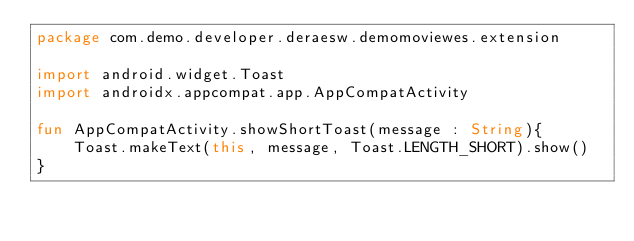Convert code to text. <code><loc_0><loc_0><loc_500><loc_500><_Kotlin_>package com.demo.developer.deraesw.demomoviewes.extension

import android.widget.Toast
import androidx.appcompat.app.AppCompatActivity

fun AppCompatActivity.showShortToast(message : String){
    Toast.makeText(this, message, Toast.LENGTH_SHORT).show()
}
</code> 